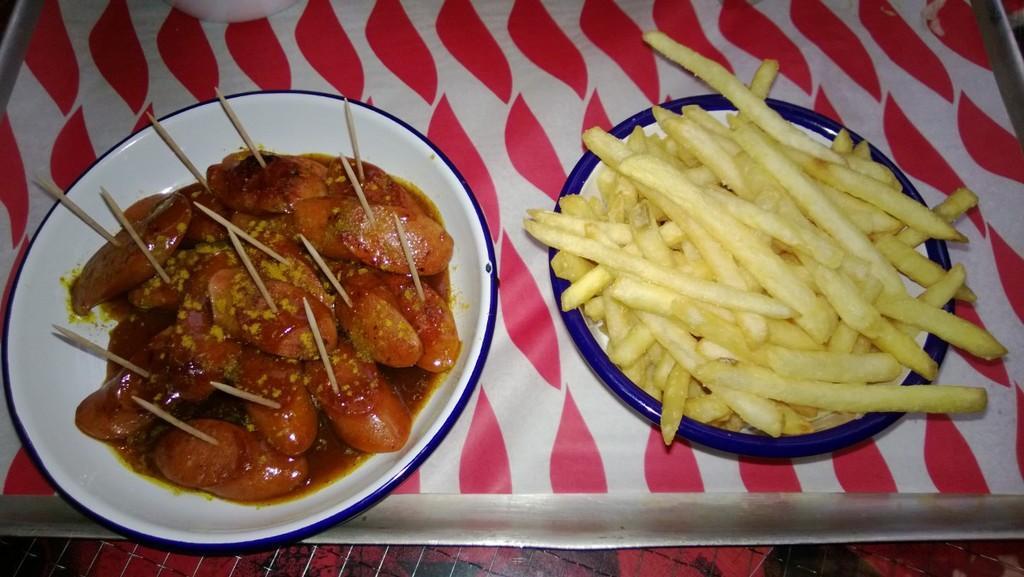How would you summarize this image in a sentence or two? In this image we can see french fries and other food item with toothpicks to them in the plates on a platform. 